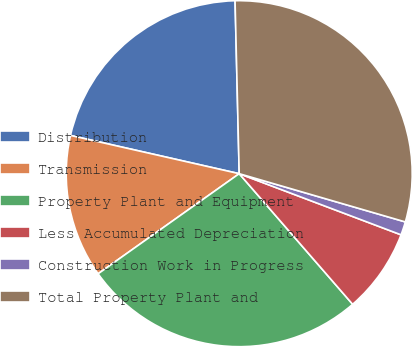Convert chart. <chart><loc_0><loc_0><loc_500><loc_500><pie_chart><fcel>Distribution<fcel>Transmission<fcel>Property Plant and Equipment<fcel>Less Accumulated Depreciation<fcel>Construction Work in Progress<fcel>Total Property Plant and<nl><fcel>21.07%<fcel>13.37%<fcel>26.56%<fcel>7.87%<fcel>1.25%<fcel>29.88%<nl></chart> 